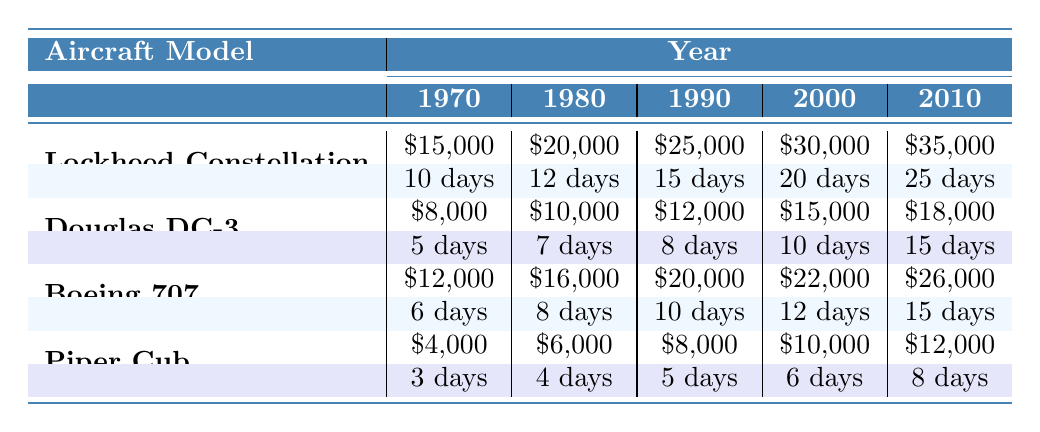What was the maintenance cost for the Lockheed Constellation in 1980? The table shows that in 1980, the maintenance cost for the Lockheed Constellation was listed as $20,000.
Answer: $20,000 How many downtime days did the Boeing 707 experience in 2000? According to the table, the Boeing 707 had 12 days of downtime in the year 2000.
Answer: 12 days Which aircraft model had the highest maintenance cost in 2010? By examining the values for maintenance costs in 2010, the Lockheed Constellation had the highest cost at $35,000, while other models had lower values: Douglas DC-3 at $18,000, Boeing 707 at $26,000, and Piper Cub at $12,000.
Answer: Lockheed Constellation What is the average maintenance cost of the Piper Cub from 1970 to 2010? To find the average maintenance cost for the Piper Cub, add up the costs for each year: $4,000 + $6,000 + $8,000 + $10,000 + $12,000 = $40,000. Then divide by the number of years (5), which gives an average of $40,000 / 5 = $8,000.
Answer: $8,000 True or False: The Douglas DC-3 had less downtime than the Piper Cub in 1990. In 1990, the Douglas DC-3 had 8 downtime days, while the Piper Cub had 5 downtime days, making the statement false as the DC-3 actually had more downtime than the Piper Cub.
Answer: False What was the total maintenance cost for the Boeing 707 between 1990 and 2010? The maintenance costs for the Boeing 707 in the years from 1990 to 2010 were $20,000 (1990), $22,000 (2000), and $26,000 (2010). Summing these values gives $20,000 + $22,000 + $26,000 = $68,000.
Answer: $68,000 How many downtime days did the Lockheed Constellation accumulate from 1970 to 2010? The downtime days for the Lockheed Constellation across the years are: 10 days (1970), 12 days (1980), 15 days (1990), 20 days (2000), and 25 days (2010). Adding these together: 10 + 12 + 15 + 20 + 25 = 92 days total downtime.
Answer: 92 days Which vintage aircraft had the least maintenance cost in 2000? In 2000, the maintenance costs were: Lockheed Constellation at $30,000, Douglas DC-3 at $15,000, Boeing 707 at $22,000, and Piper Cub at $10,000. Therefore, the Piper Cub had the least maintenance cost at $10,000.
Answer: Piper Cub 